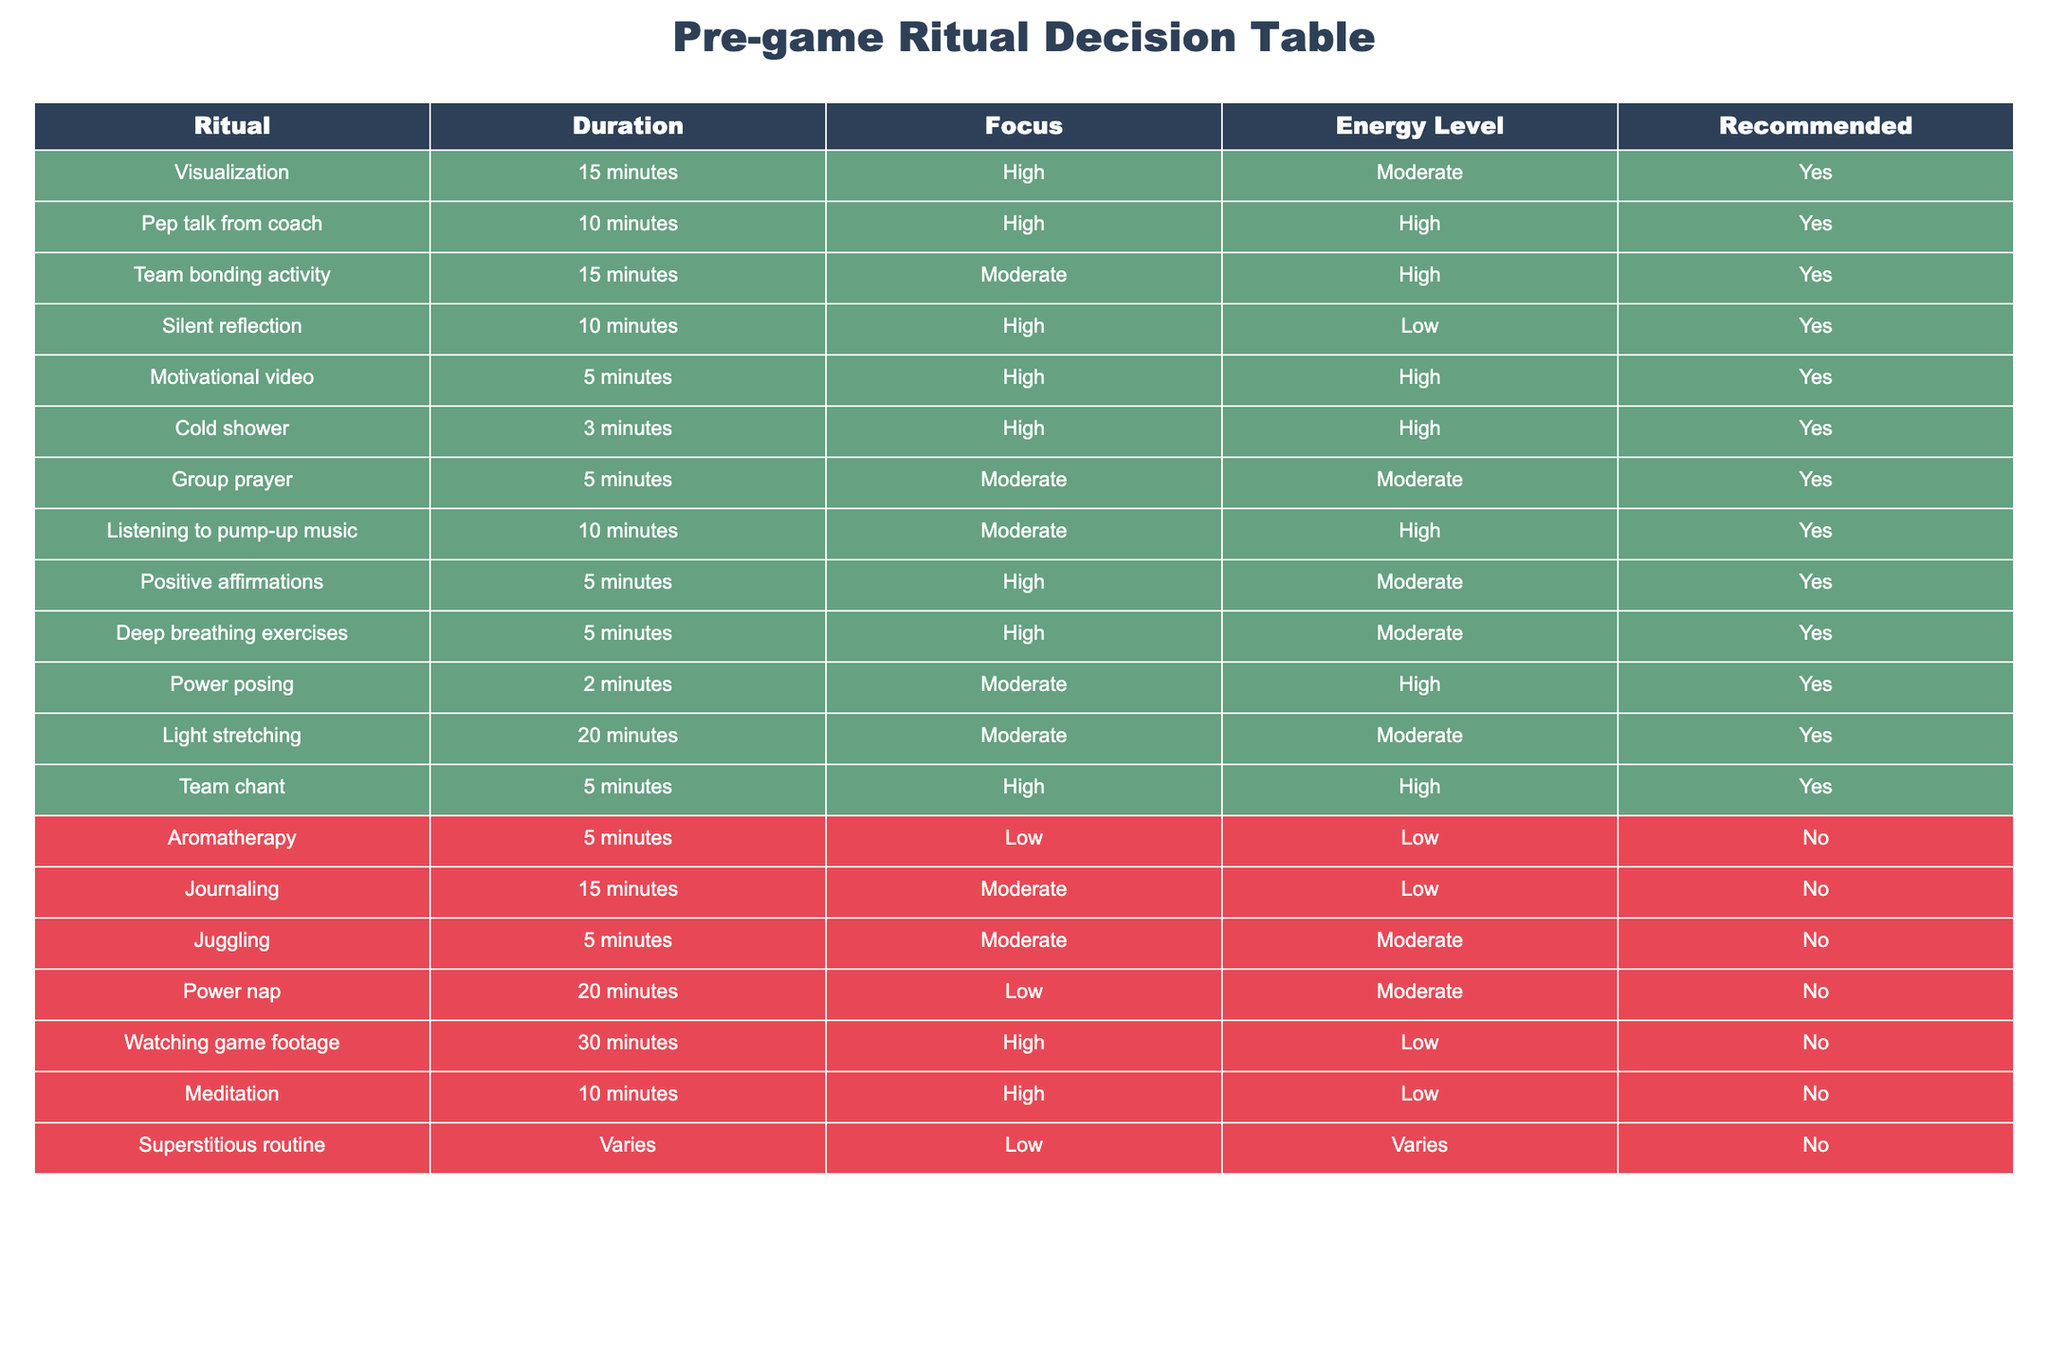What is the duration of the team chant? According to the table, the duration for the team chant ritual is listed as 5 minutes.
Answer: 5 minutes Which rituals are recommended for high focus? To find the rituals recommended for high focus, we look at the "Focus" column and find entries marked as "High." The recommended rituals for high focus are Visualization, Team chant, Deep breathing exercises, Pep talk from coach, Cold shower, Motivational video, Silent reflection, and Positive affirmations.
Answer: Visualization, Team chant, Deep breathing exercises, Pep talk from coach, Cold shower, Motivational video, Silent reflection, Positive affirmations How many rituals have a duration of 20 minutes or more? We examine the "Duration" column to count the rituals that are 20 minutes or longer. The rituals that meet this criterion are Light stretching (20 minutes) and Watching game footage (30 minutes). Thus, there are 2 rituals with a duration of 20 minutes or more.
Answer: 2 Are there any rituals that involve low energy levels but are still recommended? We check the "Energy Level" column for any "Low" entries that also have "Yes" in the "Recommended" column. The table shows that there are no rituals that have a low energy level and are also recommended.
Answer: No What is the average duration of recommended rituals? To find the average duration of recommended rituals, we first list all the durations for those that are recommended: 15, 10, 5, 20, 2, 10, 5, 10, 20, 15, 5. The total duration is 15 + 10 + 5 + 20 + 2 + 10 + 5 + 10 + 20 + 15 + 5 = 110 minutes. There are 11 recommended rituals, so the average duration is 110/11 = 10 minutes.
Answer: 10 minutes 